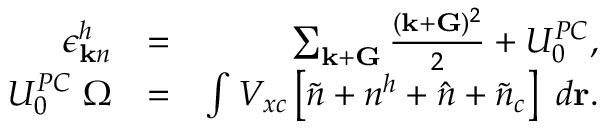Convert formula to latex. <formula><loc_0><loc_0><loc_500><loc_500>\begin{array} { r l r } { \epsilon _ { { k } n } ^ { h } } & { = } & { \sum _ { { k } + { G } } \frac { ( { k } + { G } ) ^ { 2 } } { 2 } + U _ { 0 } ^ { P C } , } \\ { U _ { 0 } ^ { P C } \Omega } & { = } & { \int V _ { x c } \left [ \tilde { n } + n ^ { h } + \hat { n } + \tilde { n } _ { c } \right ] d { r } . } \end{array}</formula> 